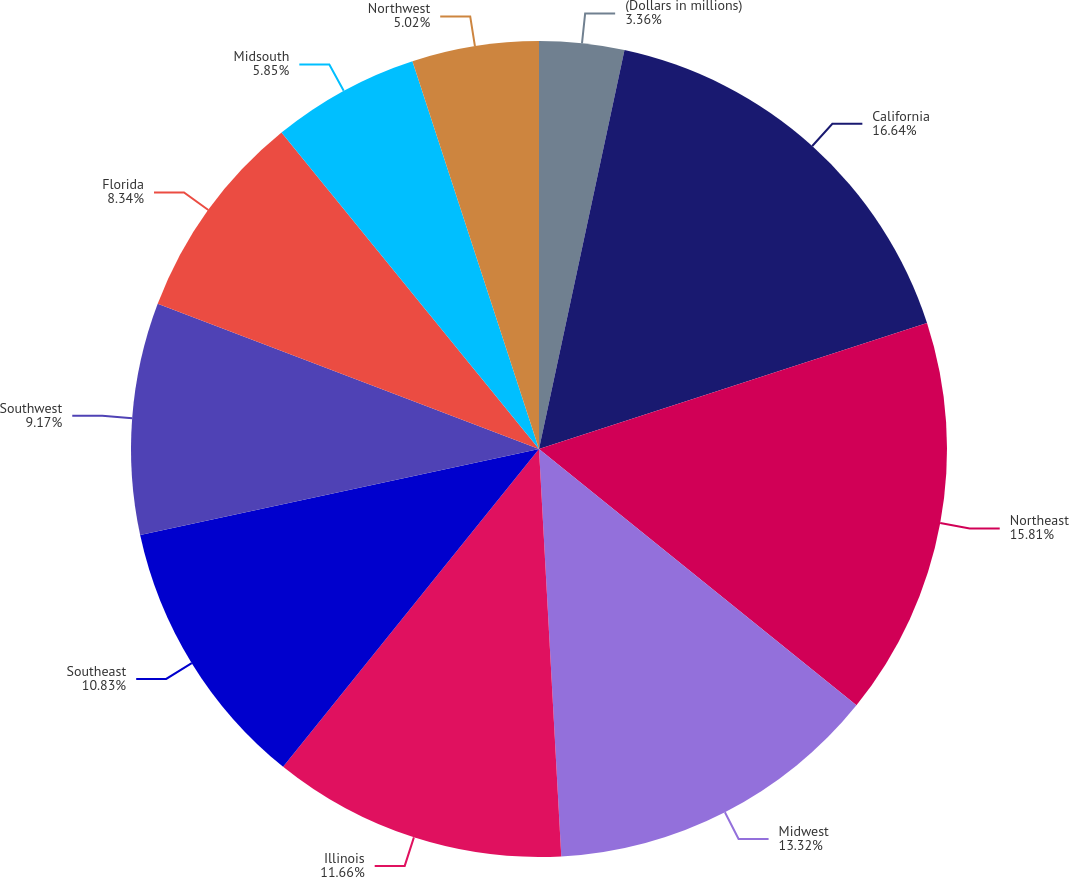Convert chart. <chart><loc_0><loc_0><loc_500><loc_500><pie_chart><fcel>(Dollars in millions)<fcel>California<fcel>Northeast<fcel>Midwest<fcel>Illinois<fcel>Southeast<fcel>Southwest<fcel>Florida<fcel>Midsouth<fcel>Northwest<nl><fcel>3.36%<fcel>16.64%<fcel>15.81%<fcel>13.32%<fcel>11.66%<fcel>10.83%<fcel>9.17%<fcel>8.34%<fcel>5.85%<fcel>5.02%<nl></chart> 